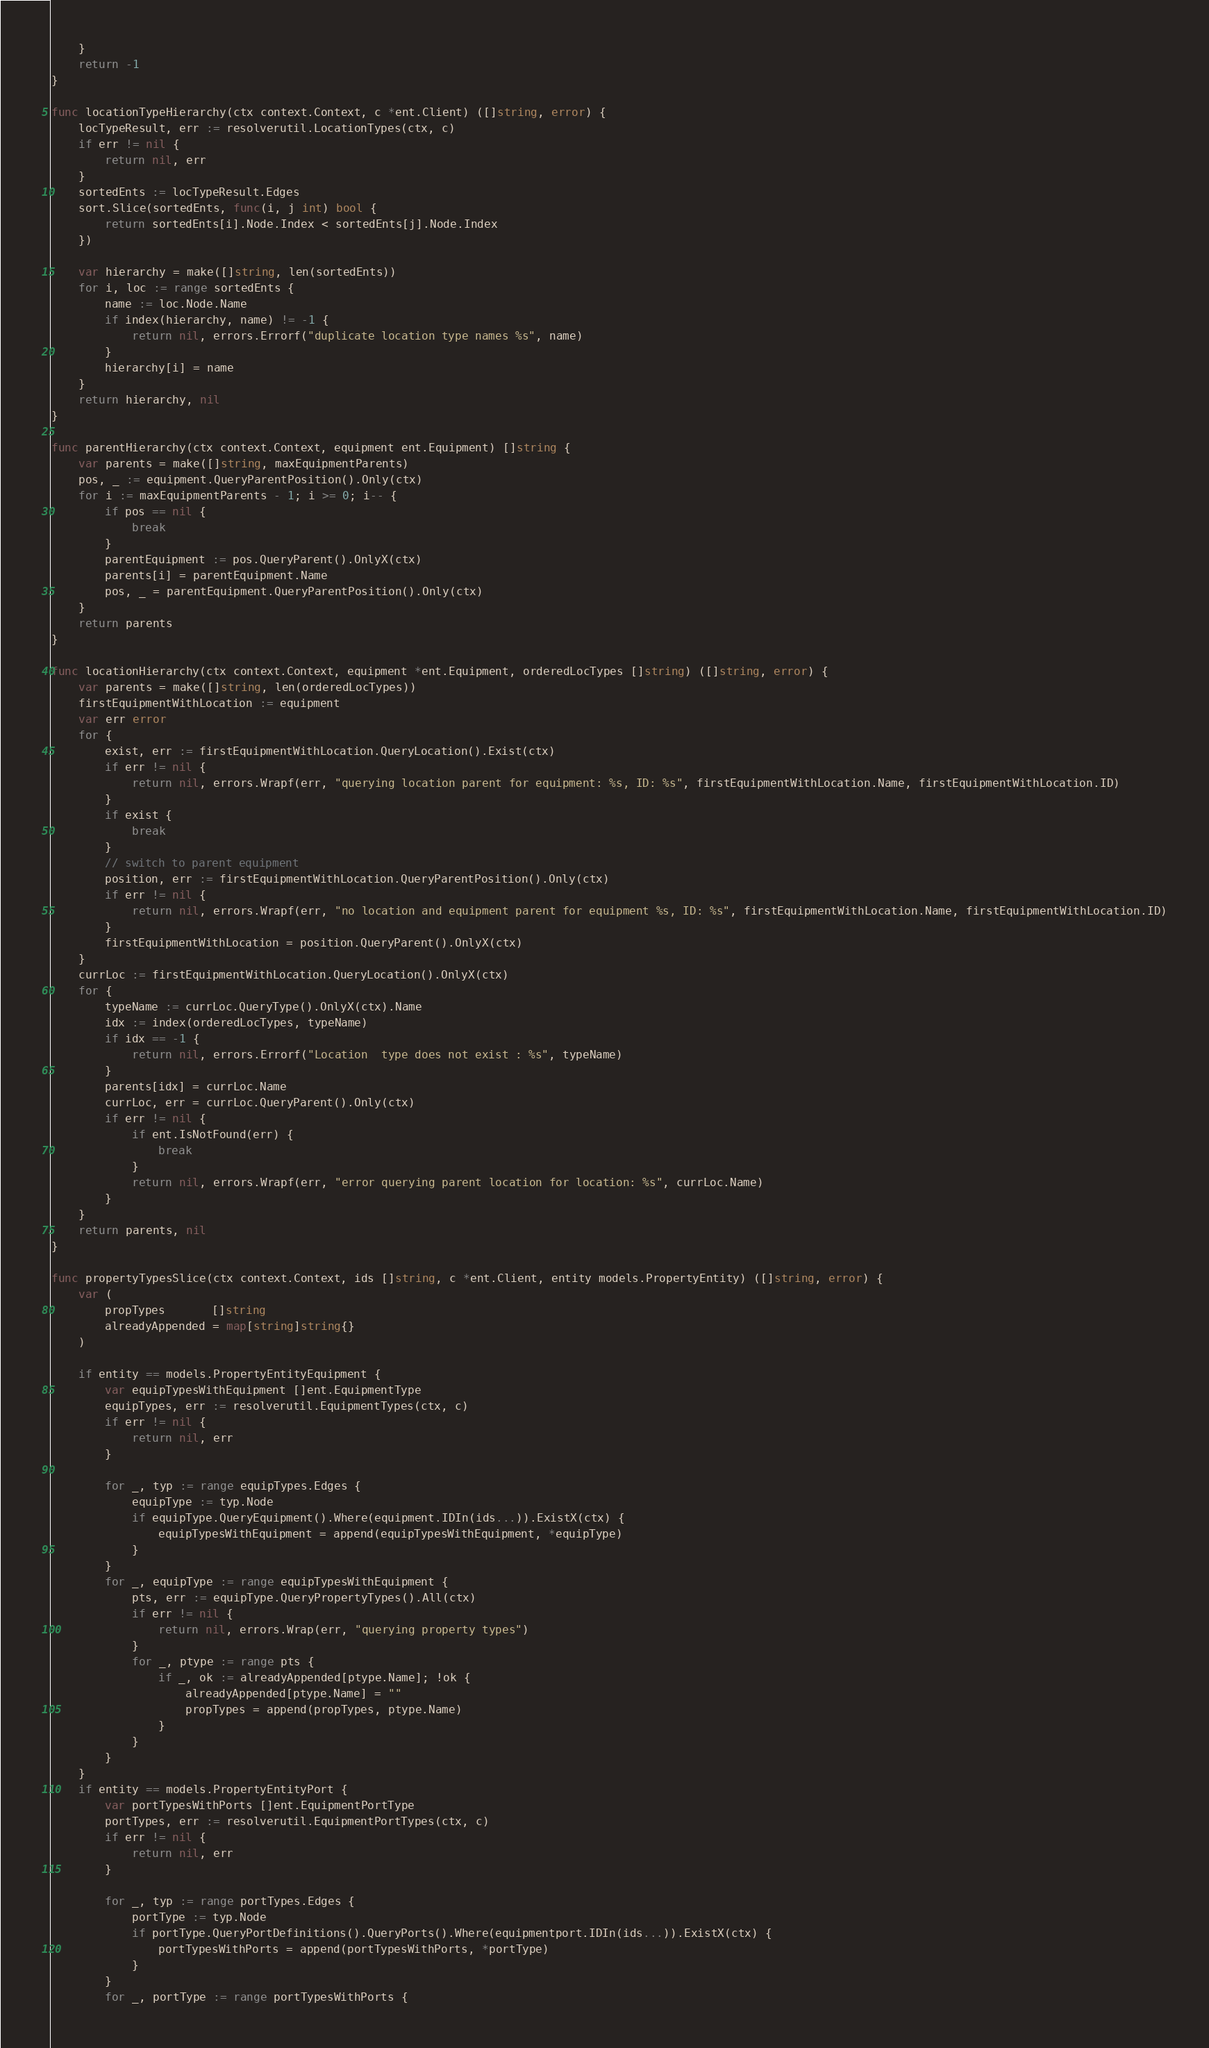<code> <loc_0><loc_0><loc_500><loc_500><_Go_>	}
	return -1
}

func locationTypeHierarchy(ctx context.Context, c *ent.Client) ([]string, error) {
	locTypeResult, err := resolverutil.LocationTypes(ctx, c)
	if err != nil {
		return nil, err
	}
	sortedEnts := locTypeResult.Edges
	sort.Slice(sortedEnts, func(i, j int) bool {
		return sortedEnts[i].Node.Index < sortedEnts[j].Node.Index
	})

	var hierarchy = make([]string, len(sortedEnts))
	for i, loc := range sortedEnts {
		name := loc.Node.Name
		if index(hierarchy, name) != -1 {
			return nil, errors.Errorf("duplicate location type names %s", name)
		}
		hierarchy[i] = name
	}
	return hierarchy, nil
}

func parentHierarchy(ctx context.Context, equipment ent.Equipment) []string {
	var parents = make([]string, maxEquipmentParents)
	pos, _ := equipment.QueryParentPosition().Only(ctx)
	for i := maxEquipmentParents - 1; i >= 0; i-- {
		if pos == nil {
			break
		}
		parentEquipment := pos.QueryParent().OnlyX(ctx)
		parents[i] = parentEquipment.Name
		pos, _ = parentEquipment.QueryParentPosition().Only(ctx)
	}
	return parents
}

func locationHierarchy(ctx context.Context, equipment *ent.Equipment, orderedLocTypes []string) ([]string, error) {
	var parents = make([]string, len(orderedLocTypes))
	firstEquipmentWithLocation := equipment
	var err error
	for {
		exist, err := firstEquipmentWithLocation.QueryLocation().Exist(ctx)
		if err != nil {
			return nil, errors.Wrapf(err, "querying location parent for equipment: %s, ID: %s", firstEquipmentWithLocation.Name, firstEquipmentWithLocation.ID)
		}
		if exist {
			break
		}
		// switch to parent equipment
		position, err := firstEquipmentWithLocation.QueryParentPosition().Only(ctx)
		if err != nil {
			return nil, errors.Wrapf(err, "no location and equipment parent for equipment %s, ID: %s", firstEquipmentWithLocation.Name, firstEquipmentWithLocation.ID)
		}
		firstEquipmentWithLocation = position.QueryParent().OnlyX(ctx)
	}
	currLoc := firstEquipmentWithLocation.QueryLocation().OnlyX(ctx)
	for {
		typeName := currLoc.QueryType().OnlyX(ctx).Name
		idx := index(orderedLocTypes, typeName)
		if idx == -1 {
			return nil, errors.Errorf("Location  type does not exist : %s", typeName)
		}
		parents[idx] = currLoc.Name
		currLoc, err = currLoc.QueryParent().Only(ctx)
		if err != nil {
			if ent.IsNotFound(err) {
				break
			}
			return nil, errors.Wrapf(err, "error querying parent location for location: %s", currLoc.Name)
		}
	}
	return parents, nil
}

func propertyTypesSlice(ctx context.Context, ids []string, c *ent.Client, entity models.PropertyEntity) ([]string, error) {
	var (
		propTypes       []string
		alreadyAppended = map[string]string{}
	)

	if entity == models.PropertyEntityEquipment {
		var equipTypesWithEquipment []ent.EquipmentType
		equipTypes, err := resolverutil.EquipmentTypes(ctx, c)
		if err != nil {
			return nil, err
		}

		for _, typ := range equipTypes.Edges {
			equipType := typ.Node
			if equipType.QueryEquipment().Where(equipment.IDIn(ids...)).ExistX(ctx) {
				equipTypesWithEquipment = append(equipTypesWithEquipment, *equipType)
			}
		}
		for _, equipType := range equipTypesWithEquipment {
			pts, err := equipType.QueryPropertyTypes().All(ctx)
			if err != nil {
				return nil, errors.Wrap(err, "querying property types")
			}
			for _, ptype := range pts {
				if _, ok := alreadyAppended[ptype.Name]; !ok {
					alreadyAppended[ptype.Name] = ""
					propTypes = append(propTypes, ptype.Name)
				}
			}
		}
	}
	if entity == models.PropertyEntityPort {
		var portTypesWithPorts []ent.EquipmentPortType
		portTypes, err := resolverutil.EquipmentPortTypes(ctx, c)
		if err != nil {
			return nil, err
		}

		for _, typ := range portTypes.Edges {
			portType := typ.Node
			if portType.QueryPortDefinitions().QueryPorts().Where(equipmentport.IDIn(ids...)).ExistX(ctx) {
				portTypesWithPorts = append(portTypesWithPorts, *portType)
			}
		}
		for _, portType := range portTypesWithPorts {</code> 